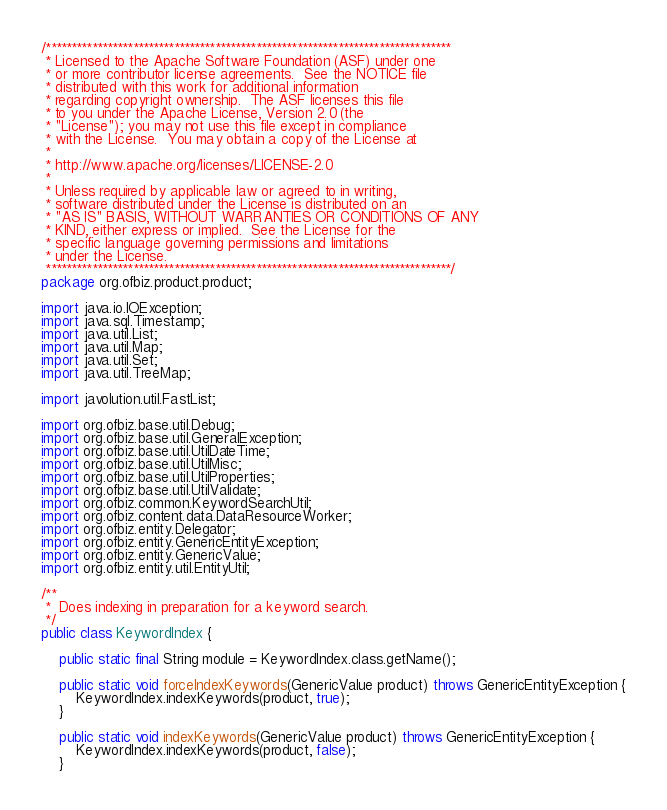Convert code to text. <code><loc_0><loc_0><loc_500><loc_500><_Java_>/*******************************************************************************
 * Licensed to the Apache Software Foundation (ASF) under one
 * or more contributor license agreements.  See the NOTICE file
 * distributed with this work for additional information
 * regarding copyright ownership.  The ASF licenses this file
 * to you under the Apache License, Version 2.0 (the
 * "License"); you may not use this file except in compliance
 * with the License.  You may obtain a copy of the License at
 *
 * http://www.apache.org/licenses/LICENSE-2.0
 *
 * Unless required by applicable law or agreed to in writing,
 * software distributed under the License is distributed on an
 * "AS IS" BASIS, WITHOUT WARRANTIES OR CONDITIONS OF ANY
 * KIND, either express or implied.  See the License for the
 * specific language governing permissions and limitations
 * under the License.
 *******************************************************************************/
package org.ofbiz.product.product;

import java.io.IOException;
import java.sql.Timestamp;
import java.util.List;
import java.util.Map;
import java.util.Set;
import java.util.TreeMap;

import javolution.util.FastList;

import org.ofbiz.base.util.Debug;
import org.ofbiz.base.util.GeneralException;
import org.ofbiz.base.util.UtilDateTime;
import org.ofbiz.base.util.UtilMisc;
import org.ofbiz.base.util.UtilProperties;
import org.ofbiz.base.util.UtilValidate;
import org.ofbiz.common.KeywordSearchUtil;
import org.ofbiz.content.data.DataResourceWorker;
import org.ofbiz.entity.Delegator;
import org.ofbiz.entity.GenericEntityException;
import org.ofbiz.entity.GenericValue;
import org.ofbiz.entity.util.EntityUtil;

/**
 *  Does indexing in preparation for a keyword search.
 */
public class KeywordIndex {

    public static final String module = KeywordIndex.class.getName();

    public static void forceIndexKeywords(GenericValue product) throws GenericEntityException {
        KeywordIndex.indexKeywords(product, true);
    }

    public static void indexKeywords(GenericValue product) throws GenericEntityException {
        KeywordIndex.indexKeywords(product, false);
    }
</code> 